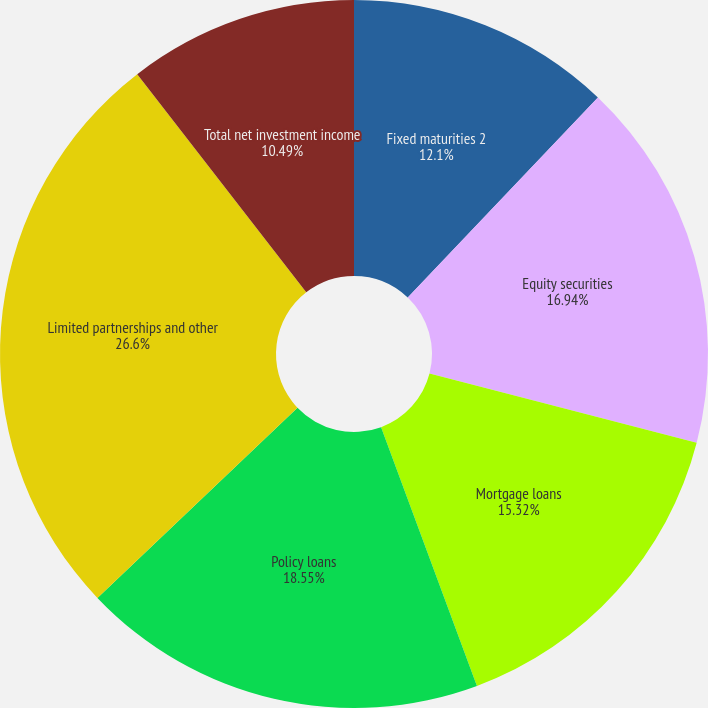Convert chart. <chart><loc_0><loc_0><loc_500><loc_500><pie_chart><fcel>Fixed maturities 2<fcel>Equity securities<fcel>Mortgage loans<fcel>Policy loans<fcel>Limited partnerships and other<fcel>Total net investment income<nl><fcel>12.1%<fcel>16.94%<fcel>15.32%<fcel>18.55%<fcel>26.61%<fcel>10.49%<nl></chart> 